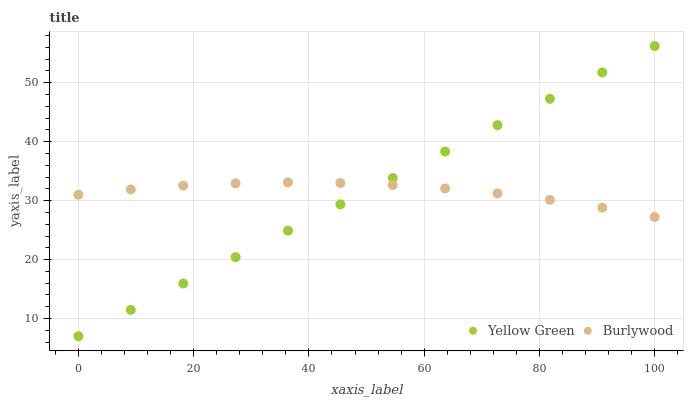Does Burlywood have the minimum area under the curve?
Answer yes or no. Yes. Does Yellow Green have the maximum area under the curve?
Answer yes or no. Yes. Does Yellow Green have the minimum area under the curve?
Answer yes or no. No. Is Yellow Green the smoothest?
Answer yes or no. Yes. Is Burlywood the roughest?
Answer yes or no. Yes. Is Yellow Green the roughest?
Answer yes or no. No. Does Yellow Green have the lowest value?
Answer yes or no. Yes. Does Yellow Green have the highest value?
Answer yes or no. Yes. Does Yellow Green intersect Burlywood?
Answer yes or no. Yes. Is Yellow Green less than Burlywood?
Answer yes or no. No. Is Yellow Green greater than Burlywood?
Answer yes or no. No. 